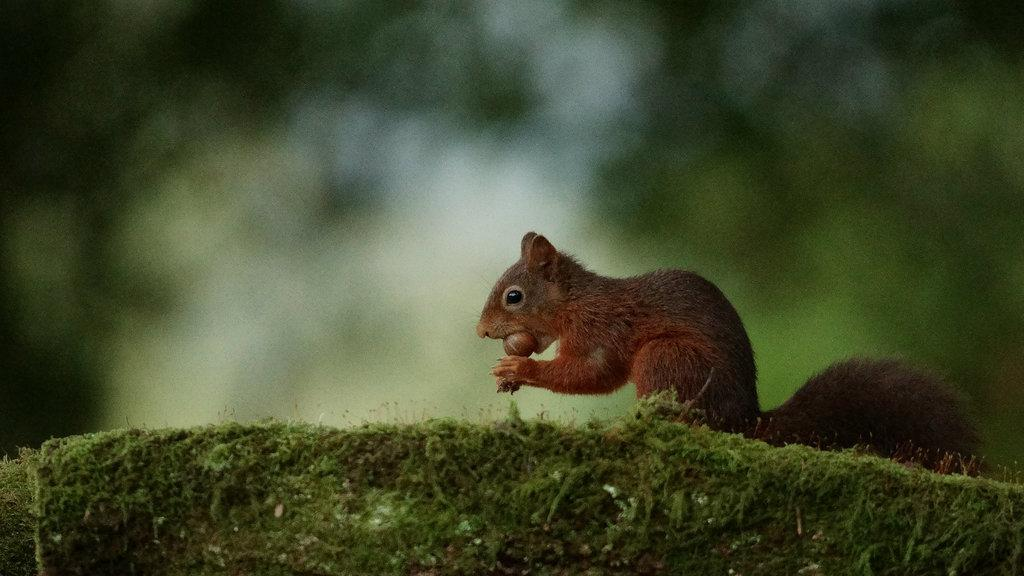What type of animal is in the image? There is a squirrel in the image. Where is the squirrel located? The squirrel is in the grass. What religious symbol can be seen in the image? There is no religious symbol present in the image; it features a squirrel in the grass. What type of rod is being used by the squirrel in the image? There is no rod present in the image; the squirrel is simply in the grass. 